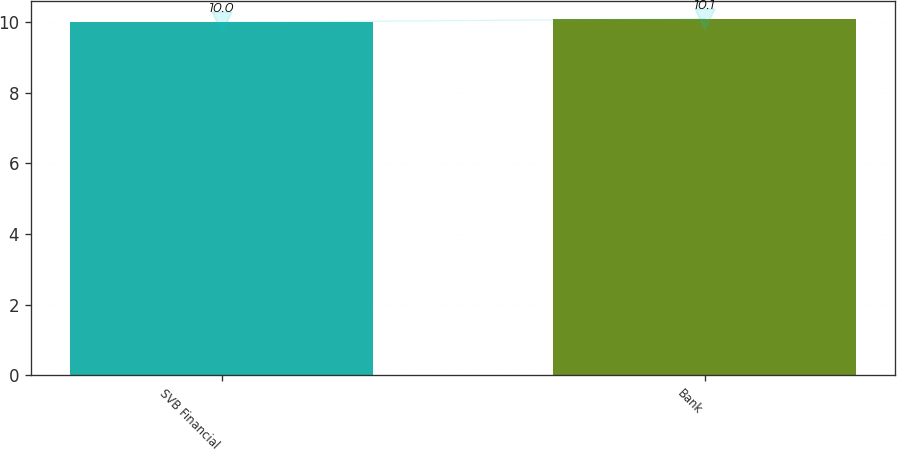<chart> <loc_0><loc_0><loc_500><loc_500><bar_chart><fcel>SVB Financial<fcel>Bank<nl><fcel>10<fcel>10.1<nl></chart> 